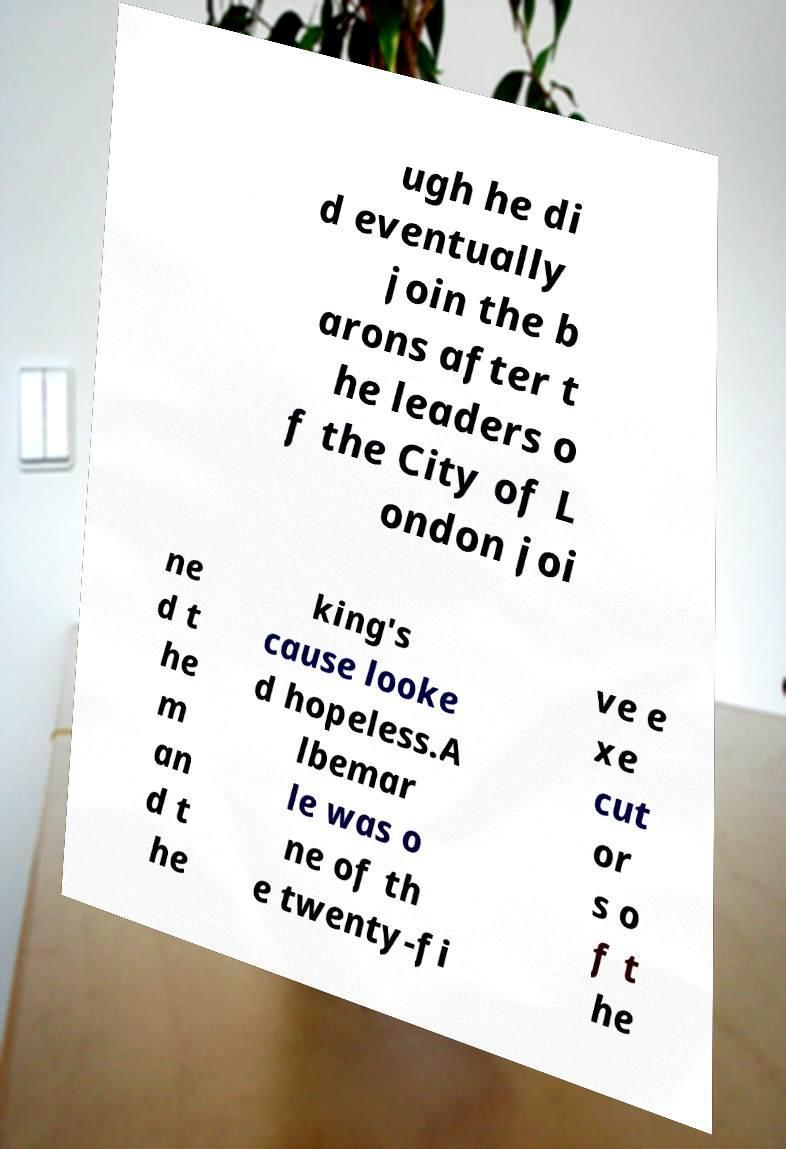Could you assist in decoding the text presented in this image and type it out clearly? ugh he di d eventually join the b arons after t he leaders o f the City of L ondon joi ne d t he m an d t he king's cause looke d hopeless.A lbemar le was o ne of th e twenty-fi ve e xe cut or s o f t he 